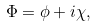Convert formula to latex. <formula><loc_0><loc_0><loc_500><loc_500>\Phi = \phi + i \chi ,</formula> 